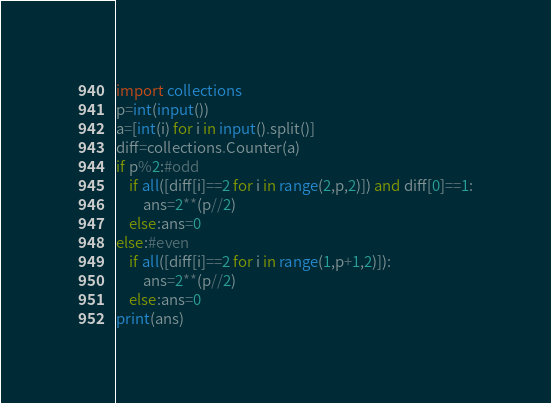Convert code to text. <code><loc_0><loc_0><loc_500><loc_500><_Python_>import collections
p=int(input())
a=[int(i) for i in input().split()]
diff=collections.Counter(a)
if p%2:#odd
    if all([diff[i]==2 for i in range(2,p,2)]) and diff[0]==1:
        ans=2**(p//2)
    else:ans=0
else:#even
    if all([diff[i]==2 for i in range(1,p+1,2)]):
        ans=2**(p//2)
    else:ans=0
print(ans)</code> 